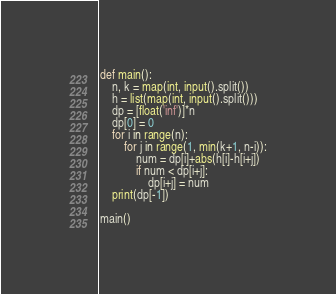Convert code to text. <code><loc_0><loc_0><loc_500><loc_500><_Python_>def main():
    n, k = map(int, input().split())
    h = list(map(int, input().split()))
    dp = [float('inf')]*n
    dp[0] = 0
    for i in range(n):
        for j in range(1, min(k+1, n-i)):
            num = dp[i]+abs(h[i]-h[i+j])
            if num < dp[i+j]:
                dp[i+j] = num
    print(dp[-1])

main()
</code> 